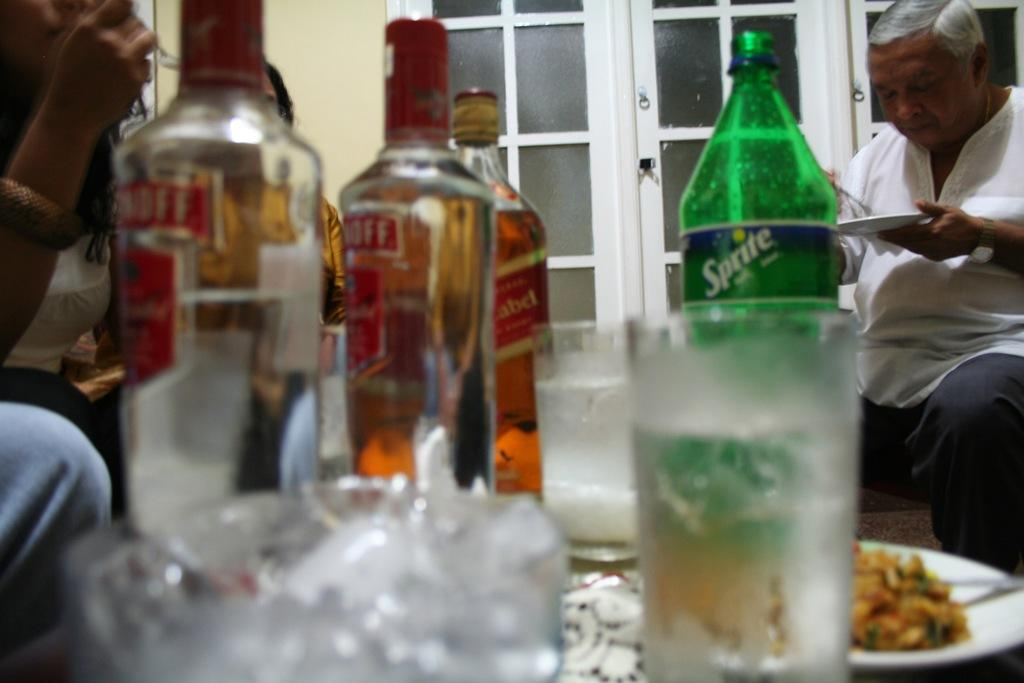<image>
Provide a brief description of the given image. Sprite is available as an alternative to the liquor on the table. 